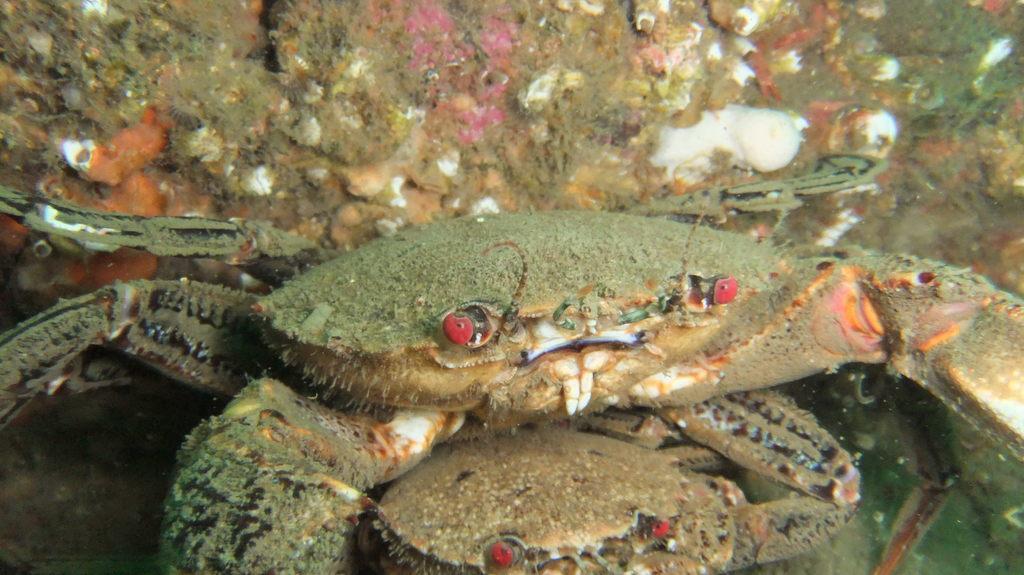Describe this image in one or two sentences. In this picture we can see the crabs and they are looking like corals in the water. 